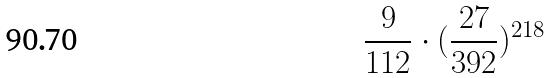Convert formula to latex. <formula><loc_0><loc_0><loc_500><loc_500>\frac { 9 } { 1 1 2 } \cdot ( \frac { 2 7 } { 3 9 2 } ) ^ { 2 1 8 }</formula> 